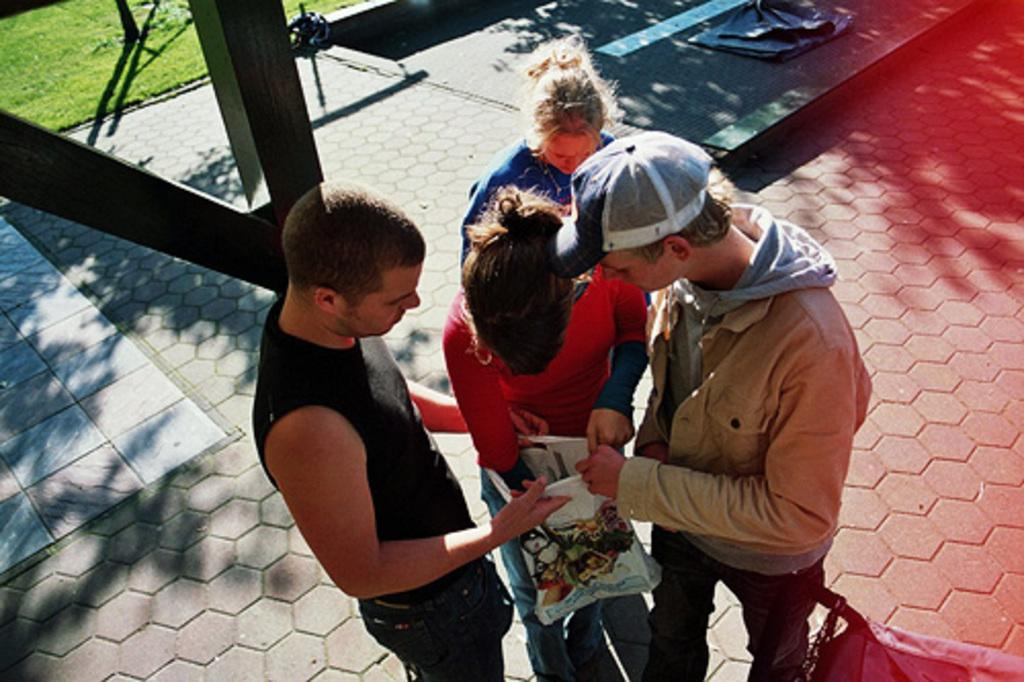What are the people in the image doing? The people in the image are standing on the floor and holding objects. What can be seen in the background of the image? There is grass visible in the image. What type of objects are the people holding? There are grills in the image. What type of joke is the grandfather telling in the image? There is no grandfather or joke present in the image. Is the person holding the grill a spy in the image? There is no indication in the image that the person holding the grill is a spy. 